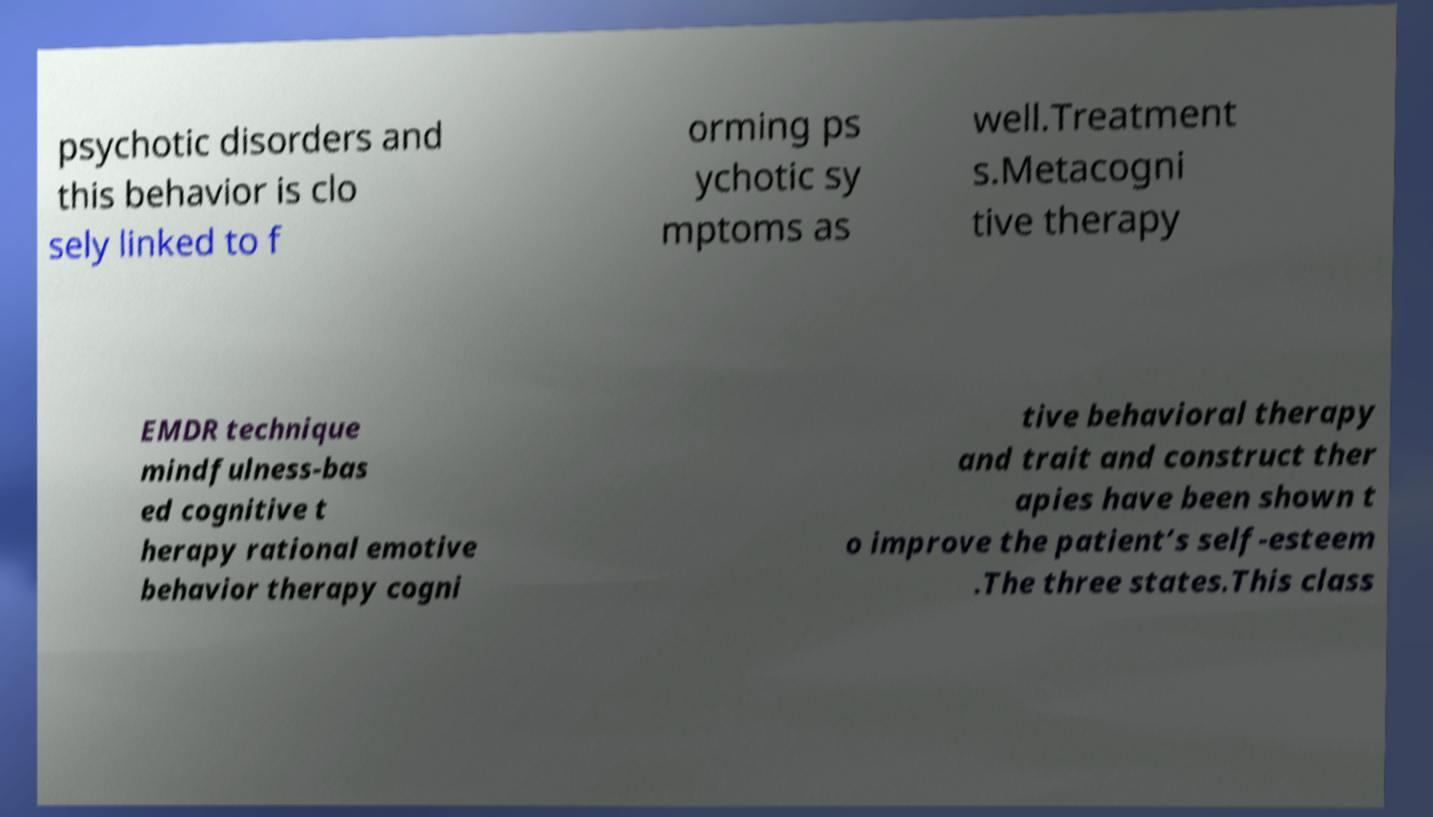Can you accurately transcribe the text from the provided image for me? psychotic disorders and this behavior is clo sely linked to f orming ps ychotic sy mptoms as well.Treatment s.Metacogni tive therapy EMDR technique mindfulness-bas ed cognitive t herapy rational emotive behavior therapy cogni tive behavioral therapy and trait and construct ther apies have been shown t o improve the patient’s self-esteem .The three states.This class 